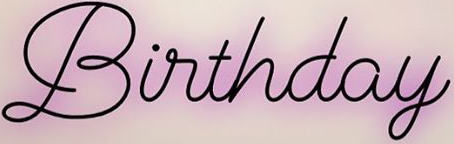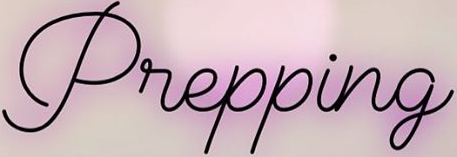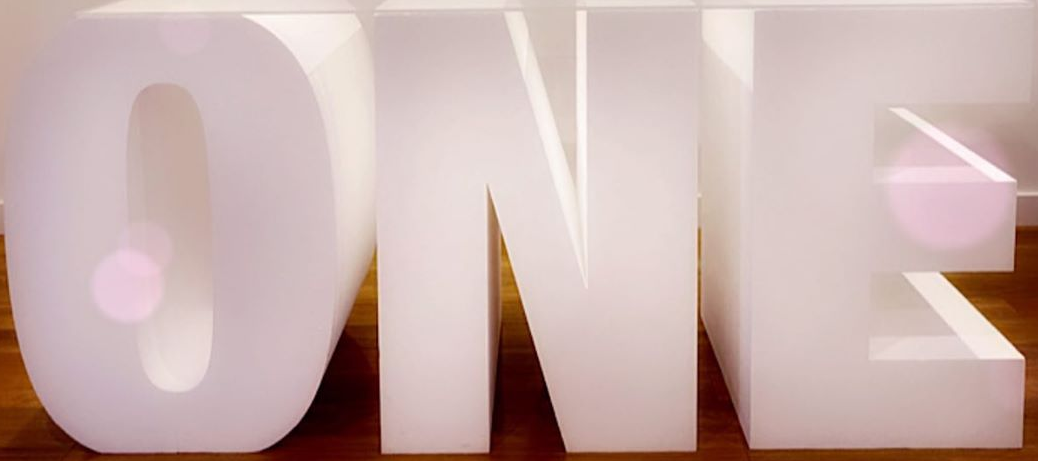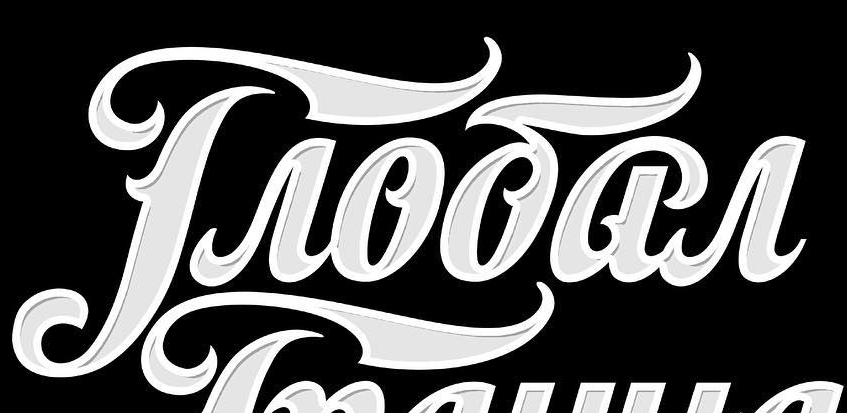What text is displayed in these images sequentially, separated by a semicolon? Birthday; Prepping; ONE; Troōar 